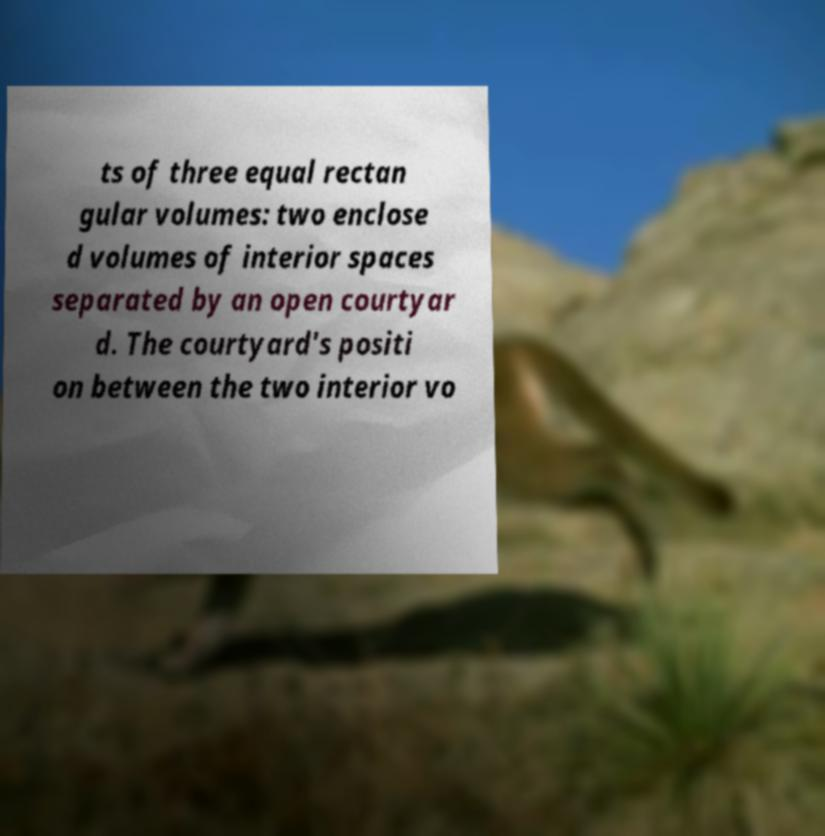Please read and relay the text visible in this image. What does it say? ts of three equal rectan gular volumes: two enclose d volumes of interior spaces separated by an open courtyar d. The courtyard's positi on between the two interior vo 